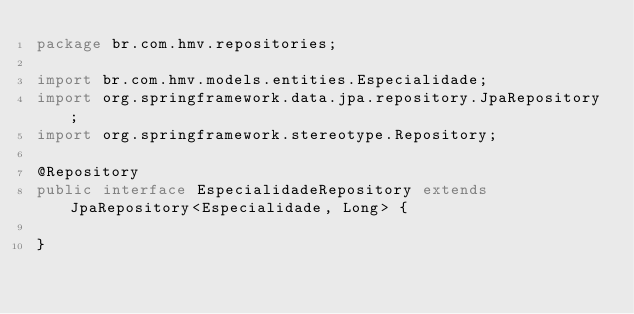<code> <loc_0><loc_0><loc_500><loc_500><_Java_>package br.com.hmv.repositories;

import br.com.hmv.models.entities.Especialidade;
import org.springframework.data.jpa.repository.JpaRepository;
import org.springframework.stereotype.Repository;

@Repository
public interface EspecialidadeRepository extends JpaRepository<Especialidade, Long> {

}
</code> 